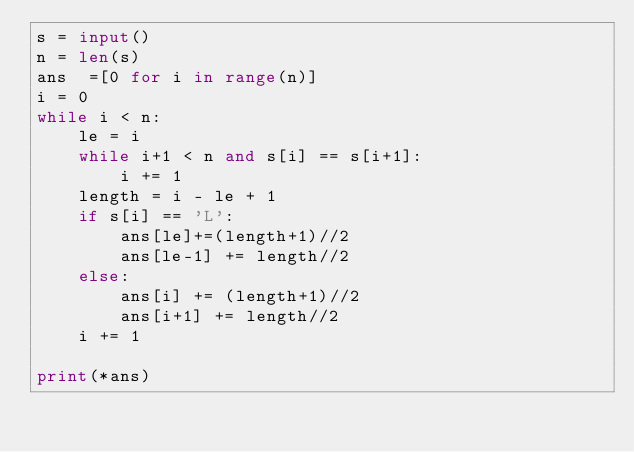Convert code to text. <code><loc_0><loc_0><loc_500><loc_500><_Python_>s = input()
n = len(s)
ans  =[0 for i in range(n)]
i = 0
while i < n:
    le = i
    while i+1 < n and s[i] == s[i+1]:
        i += 1
    length = i - le + 1
    if s[i] == 'L':
        ans[le]+=(length+1)//2
        ans[le-1] += length//2
    else:
        ans[i] += (length+1)//2
        ans[i+1] += length//2
    i += 1

print(*ans)</code> 